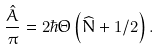<formula> <loc_0><loc_0><loc_500><loc_500>\frac { \hat { A } } { \pi } = 2 \hbar { \Theta } \left ( \widehat { N } + 1 / 2 \right ) .</formula> 